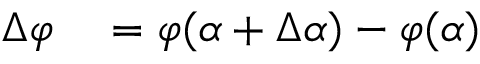<formula> <loc_0><loc_0><loc_500><loc_500>\begin{array} { r l } { \Delta \varphi } & = \varphi ( \alpha + \Delta \alpha ) - \varphi ( \alpha ) } \end{array}</formula> 